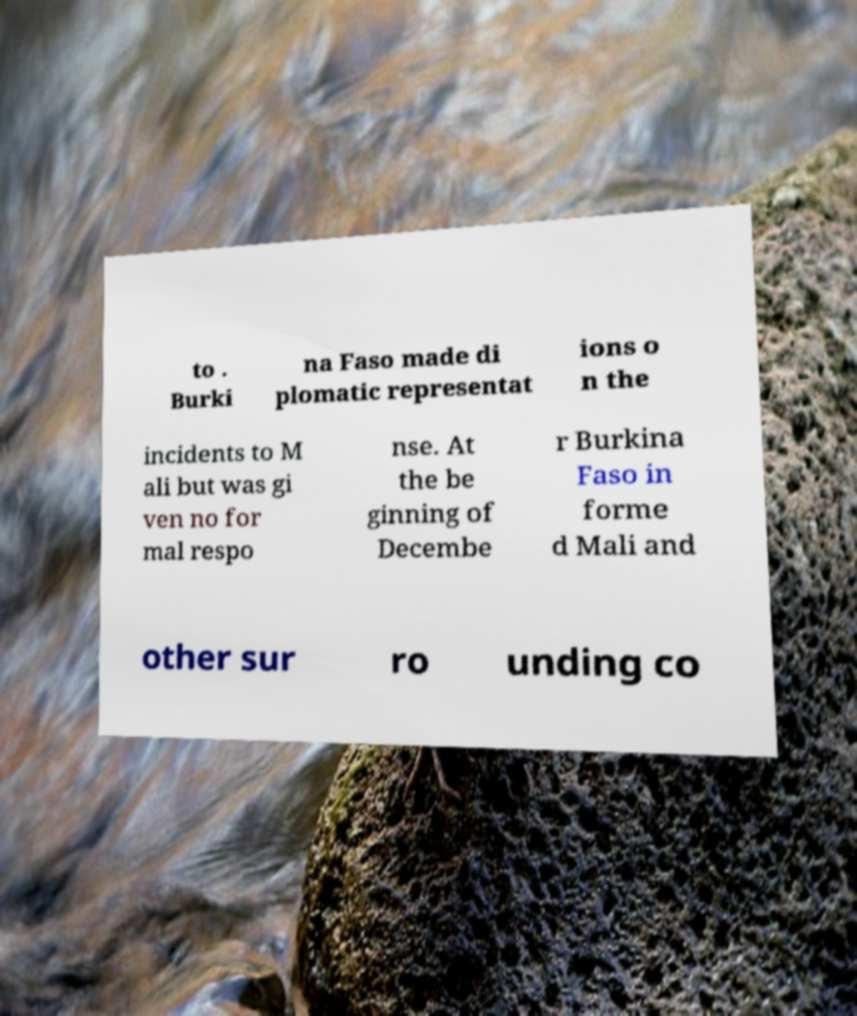Can you accurately transcribe the text from the provided image for me? to . Burki na Faso made di plomatic representat ions o n the incidents to M ali but was gi ven no for mal respo nse. At the be ginning of Decembe r Burkina Faso in forme d Mali and other sur ro unding co 